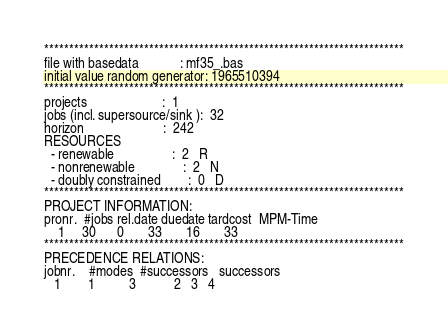Convert code to text. <code><loc_0><loc_0><loc_500><loc_500><_ObjectiveC_>************************************************************************
file with basedata            : mf35_.bas
initial value random generator: 1965510394
************************************************************************
projects                      :  1
jobs (incl. supersource/sink ):  32
horizon                       :  242
RESOURCES
  - renewable                 :  2   R
  - nonrenewable              :  2   N
  - doubly constrained        :  0   D
************************************************************************
PROJECT INFORMATION:
pronr.  #jobs rel.date duedate tardcost  MPM-Time
    1     30      0       33       16       33
************************************************************************
PRECEDENCE RELATIONS:
jobnr.    #modes  #successors   successors
   1        1          3           2   3   4</code> 